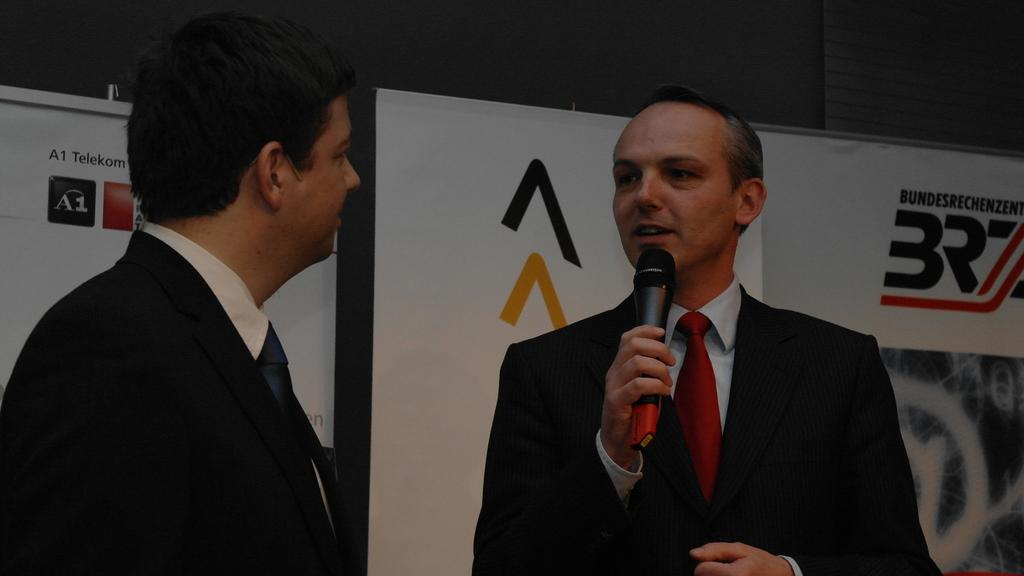How many people are in the image? There are two people in the image. What are the people wearing? Both people are wearing black suits. What is one person doing in the image? One person is holding a microphone. What else can be seen in the image besides the people? There are two banners visible in the image. Can you tell me how many birds are flying in the image? There are no birds visible in the image. What type of current is flowing through the microphone in the image? The microphone in the image is not connected to any current, as it is a standalone device. 